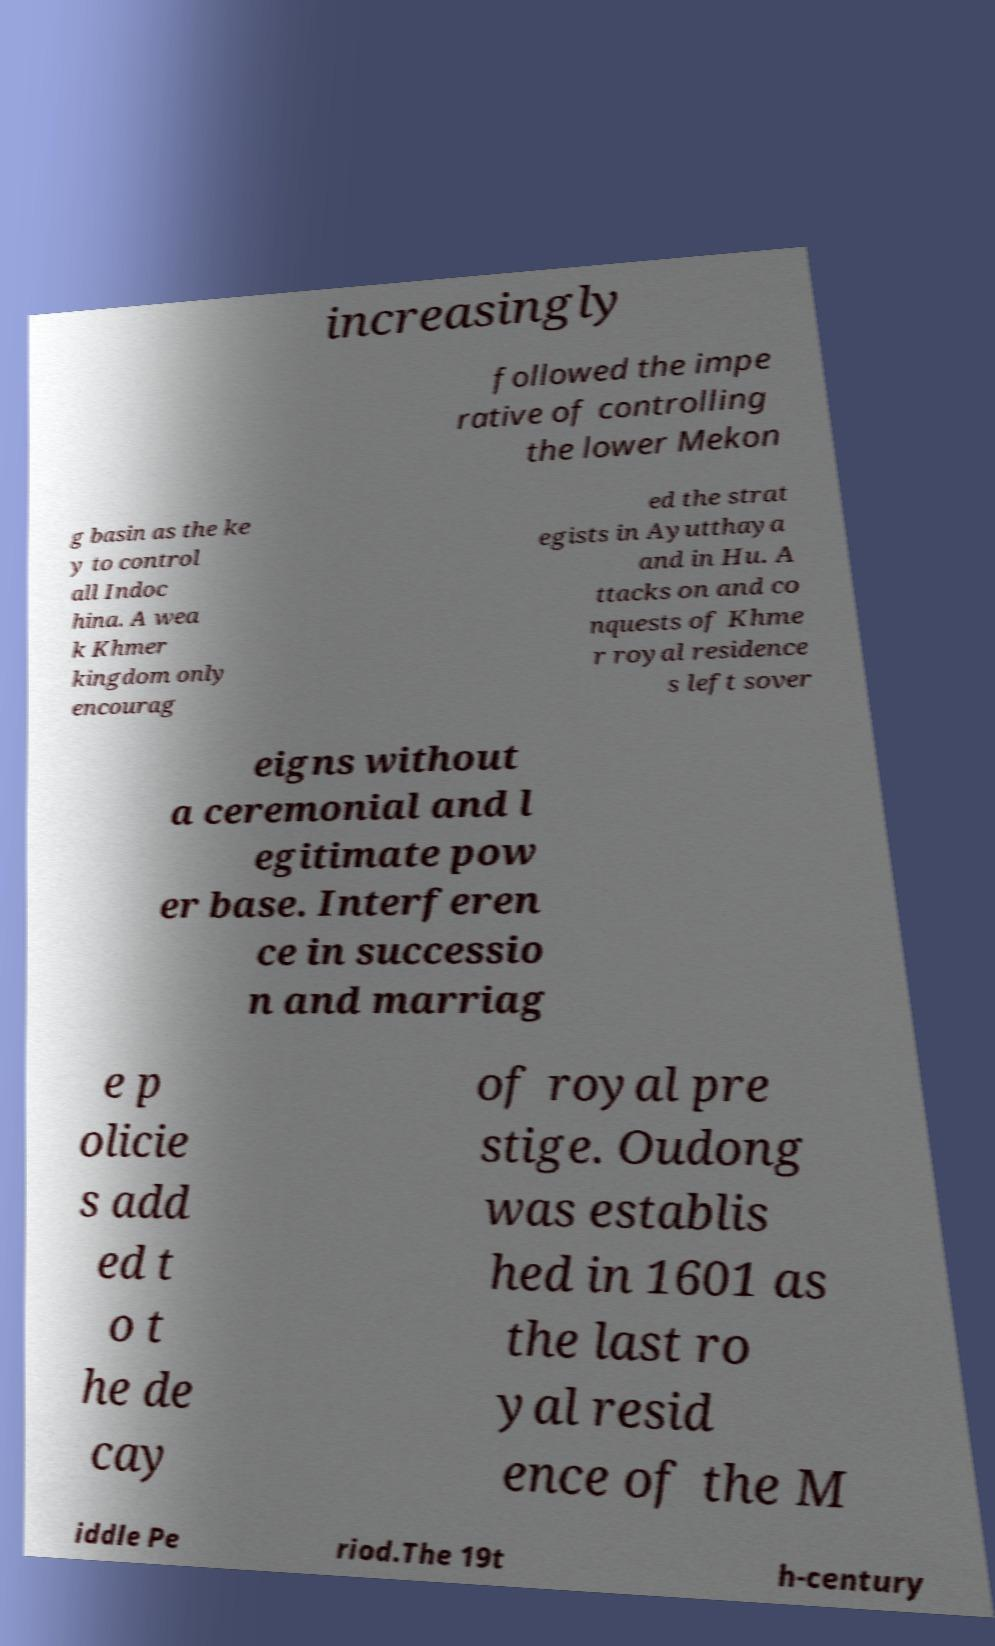There's text embedded in this image that I need extracted. Can you transcribe it verbatim? increasingly followed the impe rative of controlling the lower Mekon g basin as the ke y to control all Indoc hina. A wea k Khmer kingdom only encourag ed the strat egists in Ayutthaya and in Hu. A ttacks on and co nquests of Khme r royal residence s left sover eigns without a ceremonial and l egitimate pow er base. Interferen ce in successio n and marriag e p olicie s add ed t o t he de cay of royal pre stige. Oudong was establis hed in 1601 as the last ro yal resid ence of the M iddle Pe riod.The 19t h-century 